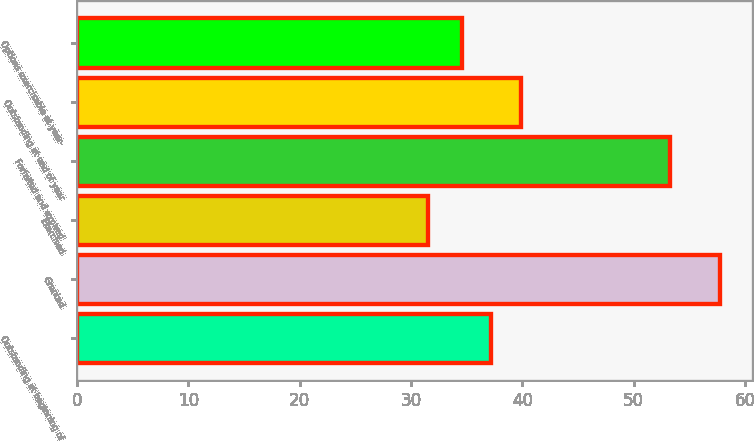Convert chart. <chart><loc_0><loc_0><loc_500><loc_500><bar_chart><fcel>Outstanding at beginning of<fcel>Granted<fcel>Exercised<fcel>Forfeited and expired<fcel>Outstanding at end of year<fcel>Options exercisable at year-<nl><fcel>37.22<fcel>57.71<fcel>31.5<fcel>53.23<fcel>39.84<fcel>34.6<nl></chart> 